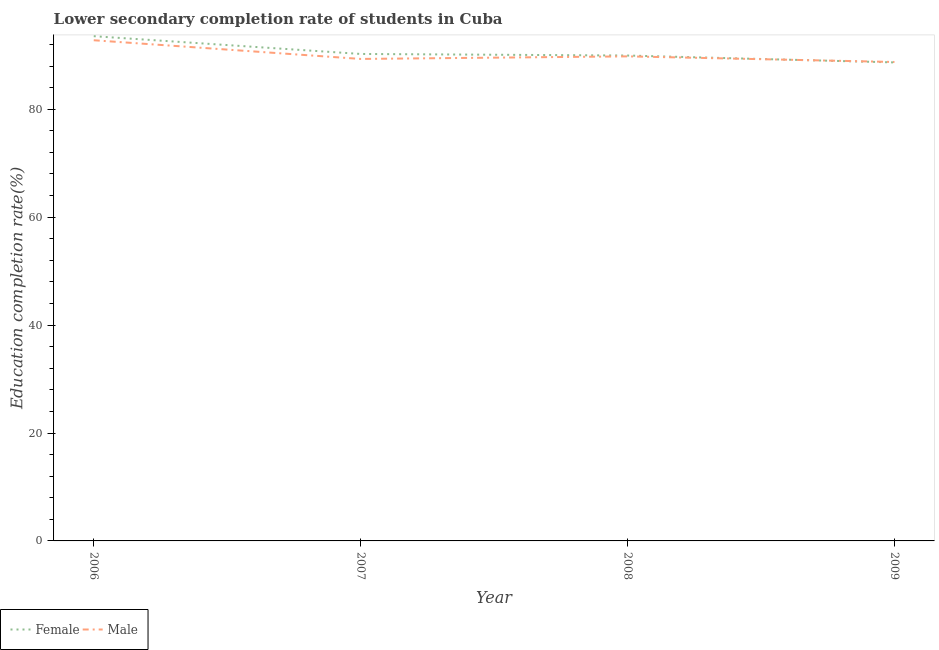How many different coloured lines are there?
Your answer should be very brief. 2. Is the number of lines equal to the number of legend labels?
Offer a terse response. Yes. What is the education completion rate of female students in 2007?
Make the answer very short. 90.25. Across all years, what is the maximum education completion rate of female students?
Offer a very short reply. 93.54. Across all years, what is the minimum education completion rate of female students?
Give a very brief answer. 88.68. In which year was the education completion rate of male students minimum?
Your response must be concise. 2009. What is the total education completion rate of female students in the graph?
Ensure brevity in your answer.  362.42. What is the difference between the education completion rate of male students in 2007 and that in 2009?
Give a very brief answer. 0.56. What is the difference between the education completion rate of female students in 2009 and the education completion rate of male students in 2006?
Provide a short and direct response. -4.11. What is the average education completion rate of female students per year?
Your answer should be compact. 90.6. In the year 2007, what is the difference between the education completion rate of female students and education completion rate of male students?
Offer a terse response. 0.92. In how many years, is the education completion rate of male students greater than 68 %?
Give a very brief answer. 4. What is the ratio of the education completion rate of male students in 2008 to that in 2009?
Your response must be concise. 1.01. Is the education completion rate of male students in 2006 less than that in 2009?
Ensure brevity in your answer.  No. Is the difference between the education completion rate of female students in 2007 and 2009 greater than the difference between the education completion rate of male students in 2007 and 2009?
Your answer should be very brief. Yes. What is the difference between the highest and the second highest education completion rate of male students?
Provide a succinct answer. 2.99. What is the difference between the highest and the lowest education completion rate of male students?
Ensure brevity in your answer.  4.03. In how many years, is the education completion rate of male students greater than the average education completion rate of male students taken over all years?
Provide a succinct answer. 1. Is the education completion rate of male students strictly less than the education completion rate of female students over the years?
Give a very brief answer. No. What is the difference between two consecutive major ticks on the Y-axis?
Offer a terse response. 20. Are the values on the major ticks of Y-axis written in scientific E-notation?
Your response must be concise. No. Does the graph contain any zero values?
Offer a terse response. No. Does the graph contain grids?
Offer a very short reply. No. How are the legend labels stacked?
Offer a terse response. Horizontal. What is the title of the graph?
Offer a terse response. Lower secondary completion rate of students in Cuba. What is the label or title of the Y-axis?
Provide a short and direct response. Education completion rate(%). What is the Education completion rate(%) of Female in 2006?
Offer a very short reply. 93.54. What is the Education completion rate(%) in Male in 2006?
Give a very brief answer. 92.79. What is the Education completion rate(%) of Female in 2007?
Offer a terse response. 90.25. What is the Education completion rate(%) of Male in 2007?
Provide a short and direct response. 89.32. What is the Education completion rate(%) in Female in 2008?
Offer a terse response. 89.95. What is the Education completion rate(%) of Male in 2008?
Offer a terse response. 89.8. What is the Education completion rate(%) of Female in 2009?
Offer a very short reply. 88.68. What is the Education completion rate(%) of Male in 2009?
Make the answer very short. 88.76. Across all years, what is the maximum Education completion rate(%) in Female?
Give a very brief answer. 93.54. Across all years, what is the maximum Education completion rate(%) in Male?
Your answer should be very brief. 92.79. Across all years, what is the minimum Education completion rate(%) in Female?
Give a very brief answer. 88.68. Across all years, what is the minimum Education completion rate(%) of Male?
Offer a terse response. 88.76. What is the total Education completion rate(%) of Female in the graph?
Keep it short and to the point. 362.42. What is the total Education completion rate(%) in Male in the graph?
Offer a terse response. 360.67. What is the difference between the Education completion rate(%) in Female in 2006 and that in 2007?
Provide a succinct answer. 3.29. What is the difference between the Education completion rate(%) of Male in 2006 and that in 2007?
Provide a succinct answer. 3.46. What is the difference between the Education completion rate(%) of Female in 2006 and that in 2008?
Offer a terse response. 3.58. What is the difference between the Education completion rate(%) in Male in 2006 and that in 2008?
Give a very brief answer. 2.99. What is the difference between the Education completion rate(%) of Female in 2006 and that in 2009?
Provide a short and direct response. 4.86. What is the difference between the Education completion rate(%) in Male in 2006 and that in 2009?
Offer a terse response. 4.03. What is the difference between the Education completion rate(%) of Female in 2007 and that in 2008?
Provide a succinct answer. 0.29. What is the difference between the Education completion rate(%) of Male in 2007 and that in 2008?
Make the answer very short. -0.48. What is the difference between the Education completion rate(%) of Female in 2007 and that in 2009?
Keep it short and to the point. 1.57. What is the difference between the Education completion rate(%) in Male in 2007 and that in 2009?
Give a very brief answer. 0.56. What is the difference between the Education completion rate(%) in Female in 2008 and that in 2009?
Your answer should be compact. 1.28. What is the difference between the Education completion rate(%) of Male in 2008 and that in 2009?
Your answer should be very brief. 1.04. What is the difference between the Education completion rate(%) in Female in 2006 and the Education completion rate(%) in Male in 2007?
Your answer should be compact. 4.22. What is the difference between the Education completion rate(%) of Female in 2006 and the Education completion rate(%) of Male in 2008?
Your answer should be very brief. 3.74. What is the difference between the Education completion rate(%) in Female in 2006 and the Education completion rate(%) in Male in 2009?
Your response must be concise. 4.78. What is the difference between the Education completion rate(%) of Female in 2007 and the Education completion rate(%) of Male in 2008?
Provide a short and direct response. 0.45. What is the difference between the Education completion rate(%) in Female in 2007 and the Education completion rate(%) in Male in 2009?
Provide a short and direct response. 1.49. What is the difference between the Education completion rate(%) in Female in 2008 and the Education completion rate(%) in Male in 2009?
Provide a short and direct response. 1.2. What is the average Education completion rate(%) in Female per year?
Your answer should be very brief. 90.6. What is the average Education completion rate(%) of Male per year?
Provide a succinct answer. 90.17. In the year 2006, what is the difference between the Education completion rate(%) of Female and Education completion rate(%) of Male?
Provide a succinct answer. 0.75. In the year 2007, what is the difference between the Education completion rate(%) in Female and Education completion rate(%) in Male?
Offer a very short reply. 0.92. In the year 2008, what is the difference between the Education completion rate(%) of Female and Education completion rate(%) of Male?
Keep it short and to the point. 0.16. In the year 2009, what is the difference between the Education completion rate(%) in Female and Education completion rate(%) in Male?
Keep it short and to the point. -0.08. What is the ratio of the Education completion rate(%) of Female in 2006 to that in 2007?
Your response must be concise. 1.04. What is the ratio of the Education completion rate(%) in Male in 2006 to that in 2007?
Keep it short and to the point. 1.04. What is the ratio of the Education completion rate(%) in Female in 2006 to that in 2008?
Offer a very short reply. 1.04. What is the ratio of the Education completion rate(%) of Female in 2006 to that in 2009?
Ensure brevity in your answer.  1.05. What is the ratio of the Education completion rate(%) of Male in 2006 to that in 2009?
Give a very brief answer. 1.05. What is the ratio of the Education completion rate(%) of Male in 2007 to that in 2008?
Keep it short and to the point. 0.99. What is the ratio of the Education completion rate(%) in Female in 2007 to that in 2009?
Provide a short and direct response. 1.02. What is the ratio of the Education completion rate(%) of Male in 2007 to that in 2009?
Your answer should be very brief. 1.01. What is the ratio of the Education completion rate(%) of Female in 2008 to that in 2009?
Make the answer very short. 1.01. What is the ratio of the Education completion rate(%) of Male in 2008 to that in 2009?
Offer a very short reply. 1.01. What is the difference between the highest and the second highest Education completion rate(%) in Female?
Offer a very short reply. 3.29. What is the difference between the highest and the second highest Education completion rate(%) of Male?
Keep it short and to the point. 2.99. What is the difference between the highest and the lowest Education completion rate(%) in Female?
Offer a terse response. 4.86. What is the difference between the highest and the lowest Education completion rate(%) of Male?
Provide a succinct answer. 4.03. 